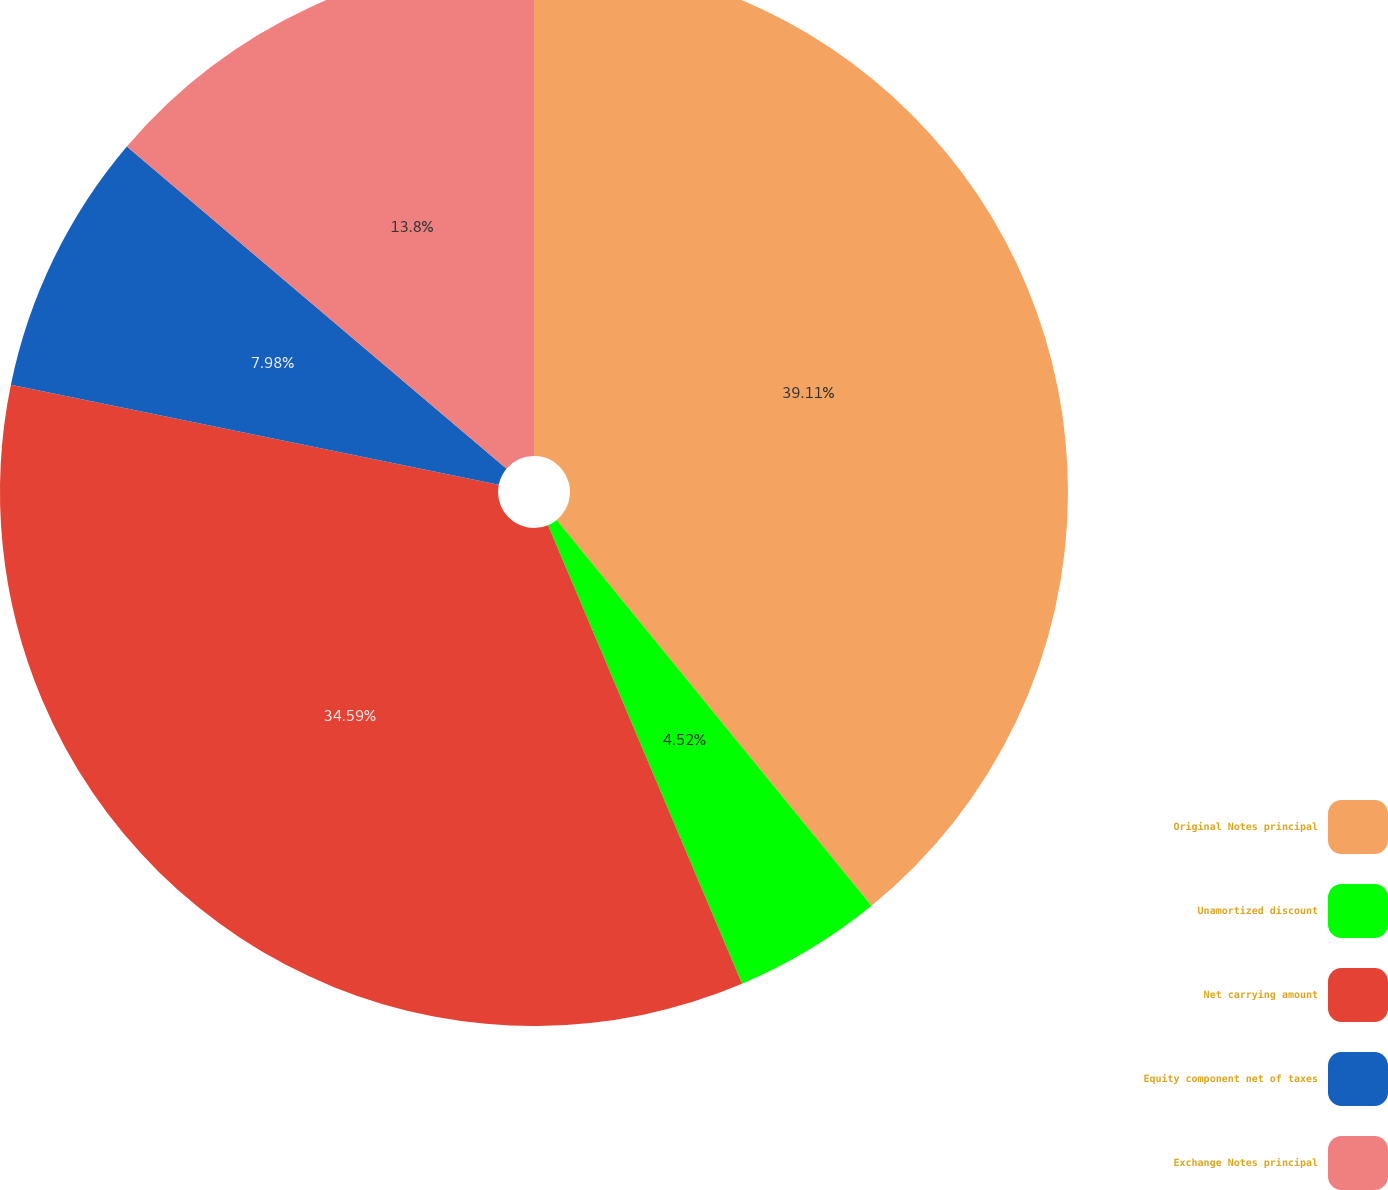<chart> <loc_0><loc_0><loc_500><loc_500><pie_chart><fcel>Original Notes principal<fcel>Unamortized discount<fcel>Net carrying amount<fcel>Equity component net of taxes<fcel>Exchange Notes principal<nl><fcel>39.11%<fcel>4.52%<fcel>34.59%<fcel>7.98%<fcel>13.8%<nl></chart> 